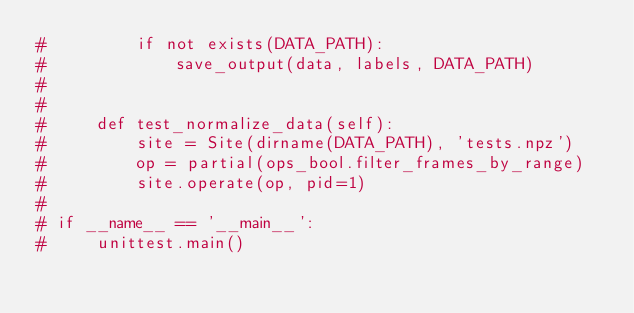Convert code to text. <code><loc_0><loc_0><loc_500><loc_500><_Python_>#         if not exists(DATA_PATH):
#             save_output(data, labels, DATA_PATH)
#
#
#     def test_normalize_data(self):
#         site = Site(dirname(DATA_PATH), 'tests.npz')
#         op = partial(ops_bool.filter_frames_by_range)
#         site.operate(op, pid=1)
#
# if __name__ == '__main__':
#     unittest.main()
</code> 